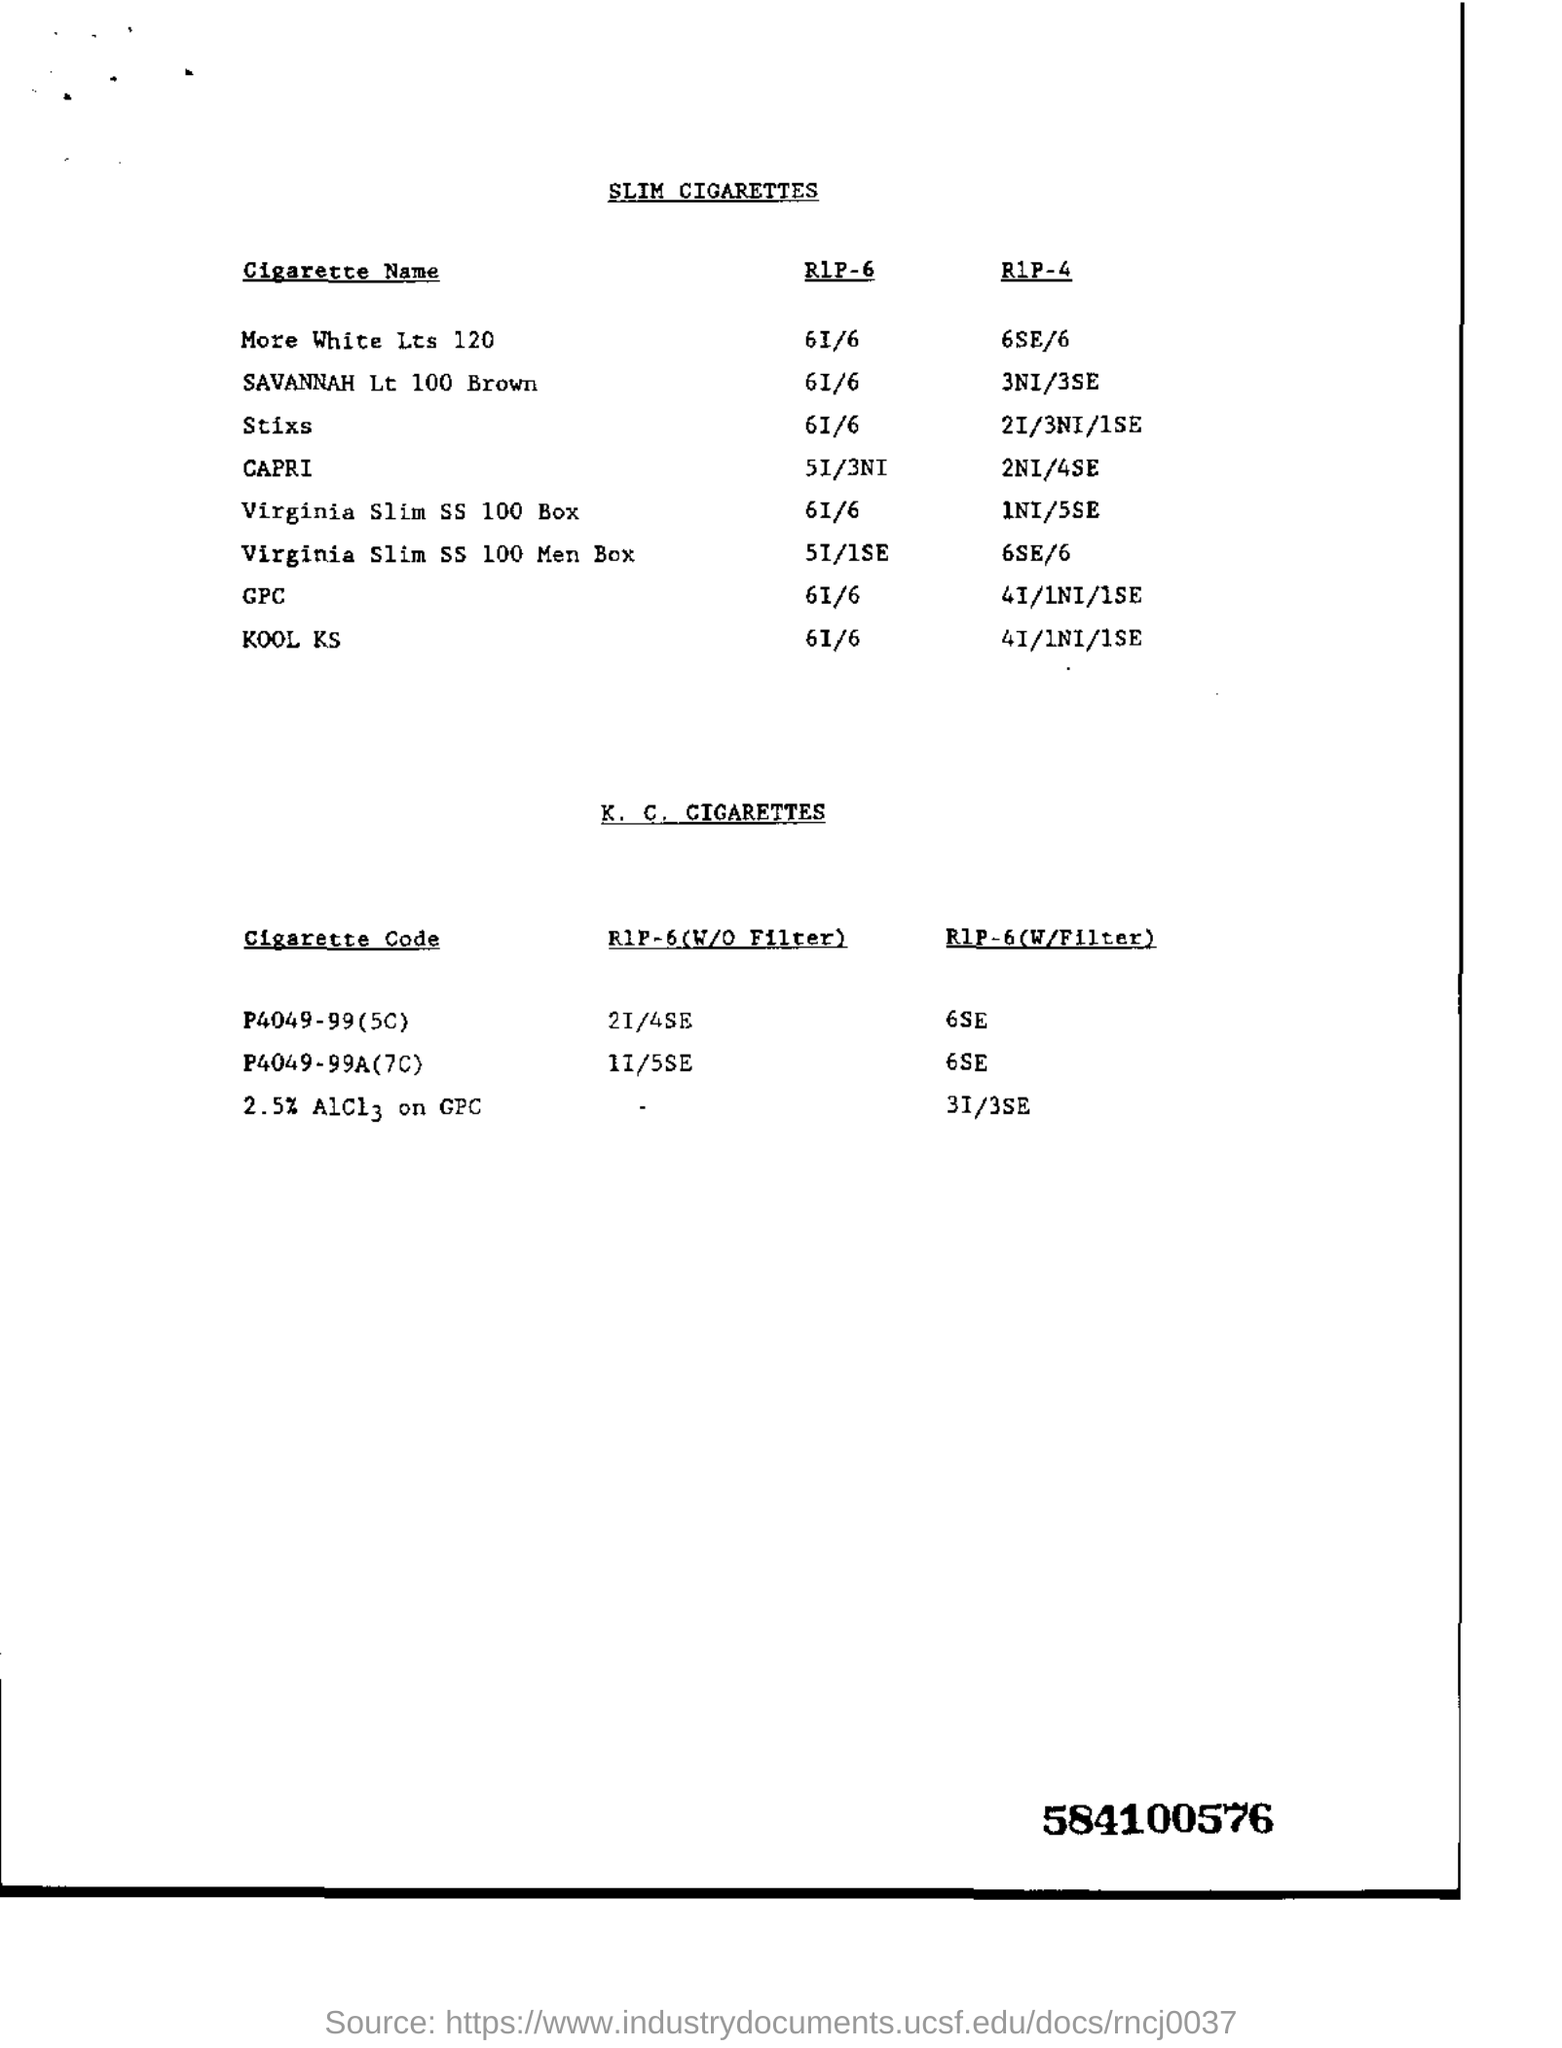What is the heading of first table?
Your answer should be compact. Slim Cigarettes. What is RIP-6 value for KOOL KS?
Provide a short and direct response. 6I/6. What is the heading of second table
Make the answer very short. K. C. Cigarettes. What is the cigarette code of RIP-6(W/O Filter) 21/4SE
Ensure brevity in your answer.  P4049-99(5C). 